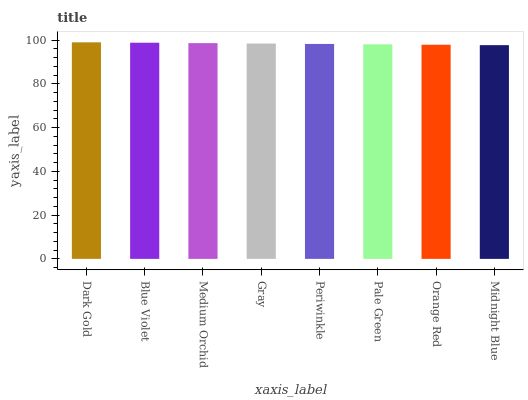Is Midnight Blue the minimum?
Answer yes or no. Yes. Is Dark Gold the maximum?
Answer yes or no. Yes. Is Blue Violet the minimum?
Answer yes or no. No. Is Blue Violet the maximum?
Answer yes or no. No. Is Dark Gold greater than Blue Violet?
Answer yes or no. Yes. Is Blue Violet less than Dark Gold?
Answer yes or no. Yes. Is Blue Violet greater than Dark Gold?
Answer yes or no. No. Is Dark Gold less than Blue Violet?
Answer yes or no. No. Is Gray the high median?
Answer yes or no. Yes. Is Periwinkle the low median?
Answer yes or no. Yes. Is Pale Green the high median?
Answer yes or no. No. Is Medium Orchid the low median?
Answer yes or no. No. 